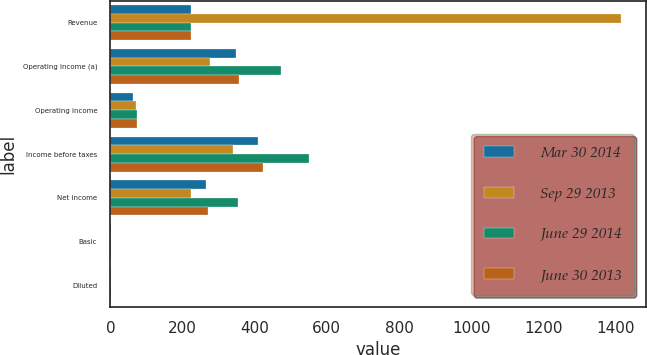<chart> <loc_0><loc_0><loc_500><loc_500><stacked_bar_chart><ecel><fcel>Revenue<fcel>Operating income (a)<fcel>Operating income<fcel>Income before taxes<fcel>Net income<fcel>Basic<fcel>Diluted<nl><fcel>Mar 30 2014<fcel>224.1<fcel>347.7<fcel>63.2<fcel>408.9<fcel>265.9<fcel>1.21<fcel>1.21<nl><fcel>Sep 29 2013<fcel>1414.2<fcel>276.8<fcel>71.5<fcel>338.5<fcel>224.1<fcel>1<fcel>0.99<nl><fcel>June 29 2014<fcel>224.1<fcel>473.3<fcel>74.4<fcel>549.1<fcel>354.2<fcel>1.63<fcel>1.62<nl><fcel>June 30 2013<fcel>224.1<fcel>357.7<fcel>74.2<fcel>422.4<fcel>271.7<fcel>1.22<fcel>1.21<nl></chart> 